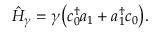Convert formula to latex. <formula><loc_0><loc_0><loc_500><loc_500>\begin{array} { r } { \hat { H } _ { \gamma } = \gamma \left ( c _ { 0 } ^ { \dagger } a _ { 1 } + a _ { 1 } ^ { \dagger } c _ { 0 } \right ) . } \end{array}</formula> 